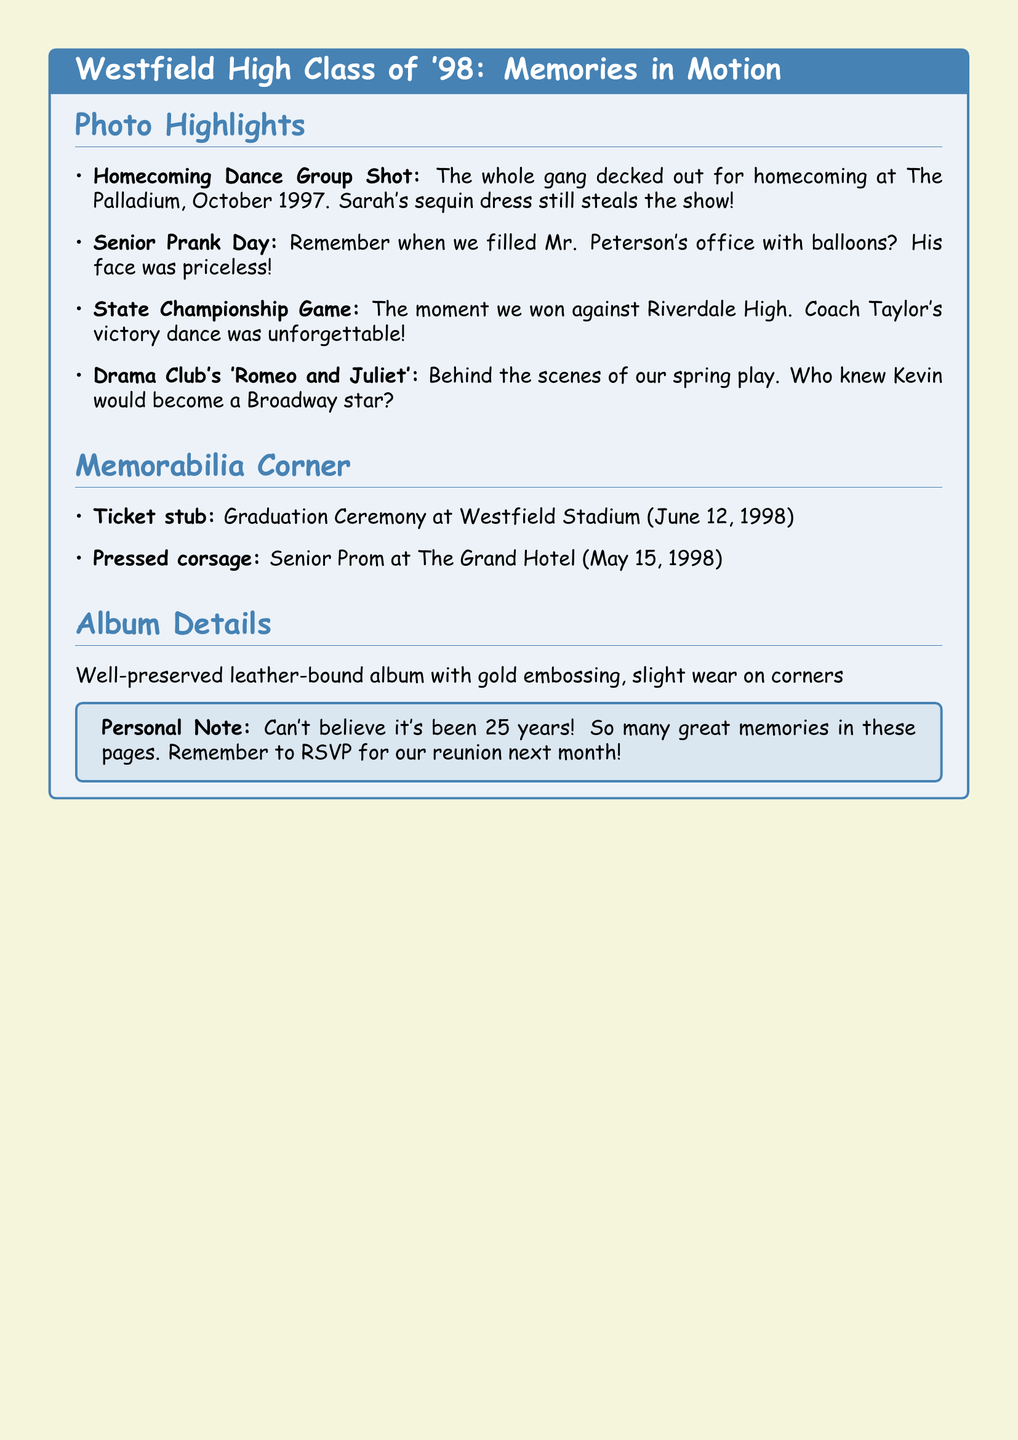What is the title of the album? The title is stated in the introduction of the document within the tcolorbox, indicating the focus on memories from Westfield High Class of '98.
Answer: Westfield High Class of '98: Memories in Motion When was the graduation ceremony held? The graduation ceremony date is listed under the memorabilia section, providing specific information about the event.
Answer: June 12, 1998 What notable event features Coach Taylor's victory dance? The event where Coach Taylor's dance took place is mentioned in the photo highlights section, indicating a moment of celebration for the team.
Answer: State Championship Game Who had a noteworthy sequin dress at the homecoming dance? The individual wearing the sequin dress is noted in the homecoming dance group shot description, highlighting her standout appearance.
Answer: Sarah What was preserved in the album from the senior prom? The memorabilia corner lists the specific item from the prom that was preserved, showing a connection to the event.
Answer: Pressed corsage What year is the reunion mentioned for? The personal note at the end of the document states the number of years since graduation, hinting at the timeline for the upcoming reunion.
Answer: 25 years Which drama club play is mentioned in the album? The play performed by the drama club is specified in the photo highlights section, marking a cultural aspect of high school life.
Answer: 'Romeo and Juliet' What unique item is mentioned from the graduation? The memorabilia corner includes a specific item that signifies the graduation event, adding to the sentimental value of the album.
Answer: Ticket stub 